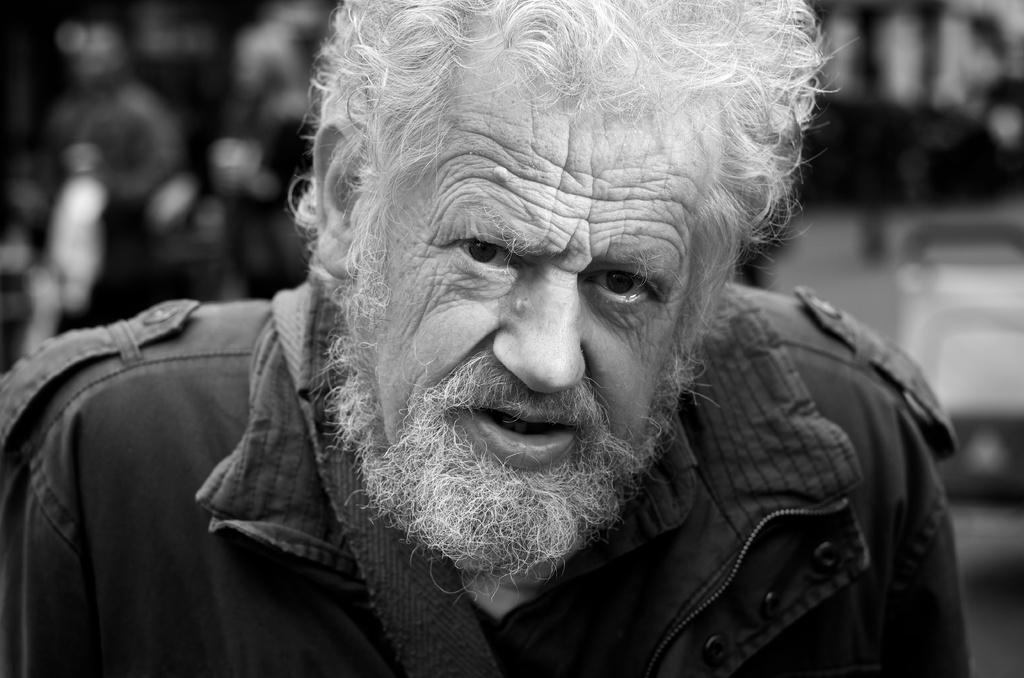What is the main subject of the image? There is a person in the image. Can you describe the background of the image? The background of the image is blurred. What color scheme is used in the image? The image is in black and white. What type of lead can be seen in the image? There is no lead present in the image. What kind of coil is visible in the image? There is no coil present in the image. 